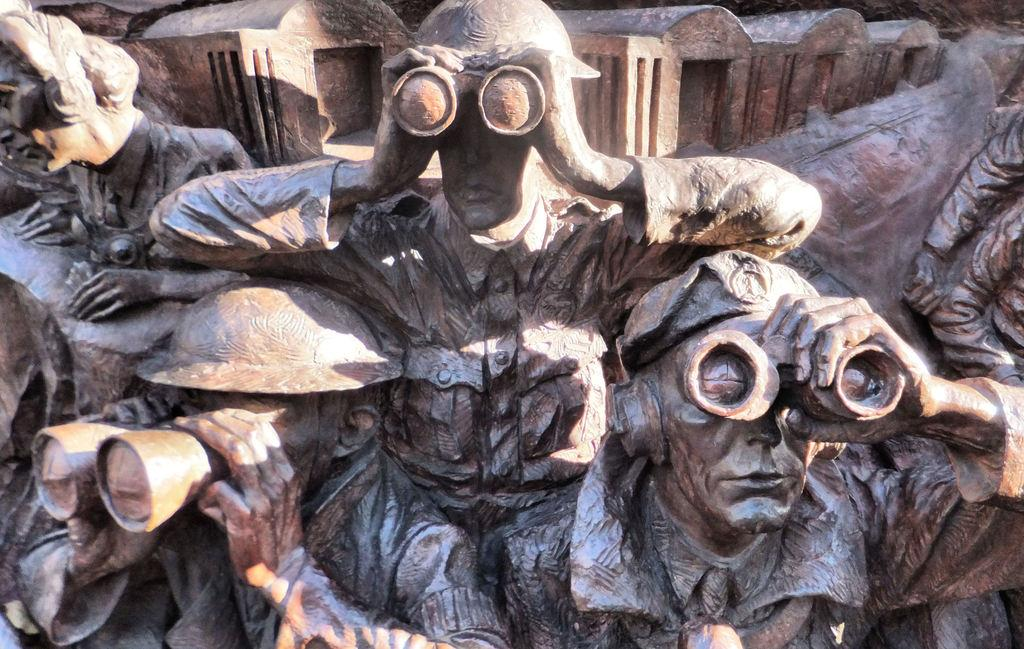What is the main subject of the image? There is a sculpture in the center of the image. How many jellyfish can be seen swimming in the river in the image? There are no jellyfish or rivers present in the image; it features a sculpture. What direction is the wind blowing in the image? There is no indication of wind or its direction in the image, as it only features a sculpture. 